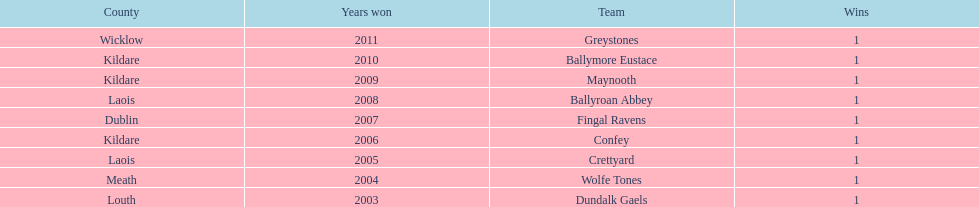What is the last team on the chart Dundalk Gaels. 